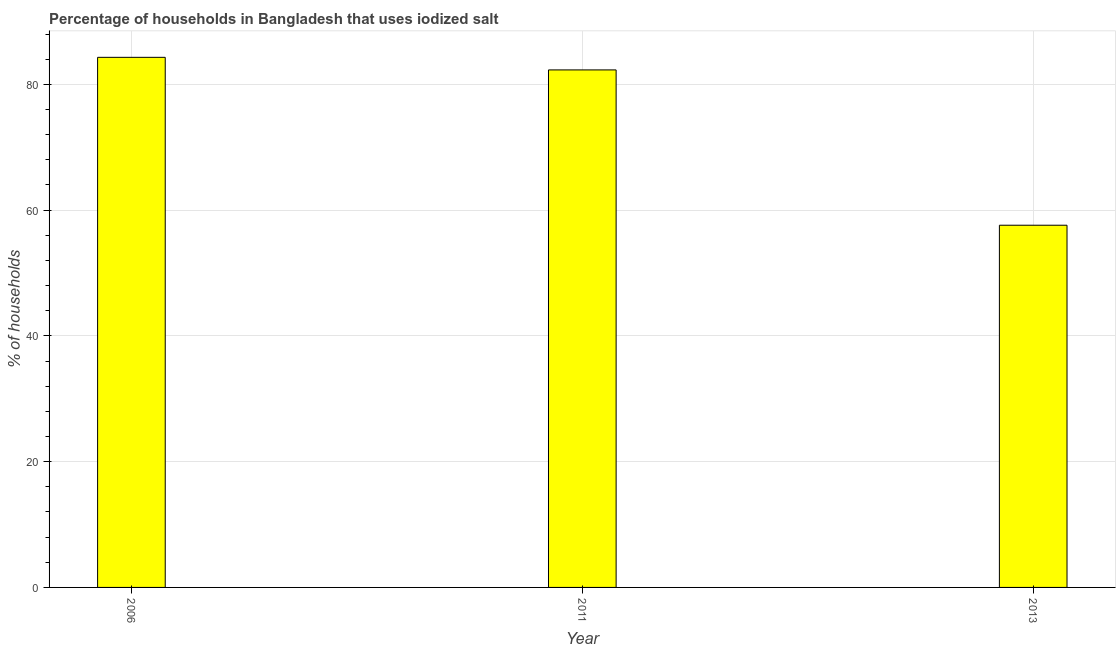What is the title of the graph?
Provide a short and direct response. Percentage of households in Bangladesh that uses iodized salt. What is the label or title of the Y-axis?
Your response must be concise. % of households. What is the percentage of households where iodized salt is consumed in 2006?
Ensure brevity in your answer.  84.3. Across all years, what is the maximum percentage of households where iodized salt is consumed?
Provide a short and direct response. 84.3. Across all years, what is the minimum percentage of households where iodized salt is consumed?
Give a very brief answer. 57.6. What is the sum of the percentage of households where iodized salt is consumed?
Provide a succinct answer. 224.2. What is the difference between the percentage of households where iodized salt is consumed in 2006 and 2013?
Your answer should be very brief. 26.7. What is the average percentage of households where iodized salt is consumed per year?
Give a very brief answer. 74.73. What is the median percentage of households where iodized salt is consumed?
Keep it short and to the point. 82.3. In how many years, is the percentage of households where iodized salt is consumed greater than 84 %?
Your answer should be compact. 1. What is the ratio of the percentage of households where iodized salt is consumed in 2011 to that in 2013?
Offer a terse response. 1.43. Is the percentage of households where iodized salt is consumed in 2006 less than that in 2013?
Provide a succinct answer. No. What is the difference between the highest and the lowest percentage of households where iodized salt is consumed?
Your answer should be compact. 26.7. In how many years, is the percentage of households where iodized salt is consumed greater than the average percentage of households where iodized salt is consumed taken over all years?
Offer a very short reply. 2. How many years are there in the graph?
Offer a very short reply. 3. Are the values on the major ticks of Y-axis written in scientific E-notation?
Your answer should be very brief. No. What is the % of households of 2006?
Keep it short and to the point. 84.3. What is the % of households of 2011?
Make the answer very short. 82.3. What is the % of households of 2013?
Provide a succinct answer. 57.6. What is the difference between the % of households in 2006 and 2011?
Your answer should be very brief. 2. What is the difference between the % of households in 2006 and 2013?
Provide a short and direct response. 26.7. What is the difference between the % of households in 2011 and 2013?
Your answer should be very brief. 24.7. What is the ratio of the % of households in 2006 to that in 2013?
Ensure brevity in your answer.  1.46. What is the ratio of the % of households in 2011 to that in 2013?
Your response must be concise. 1.43. 